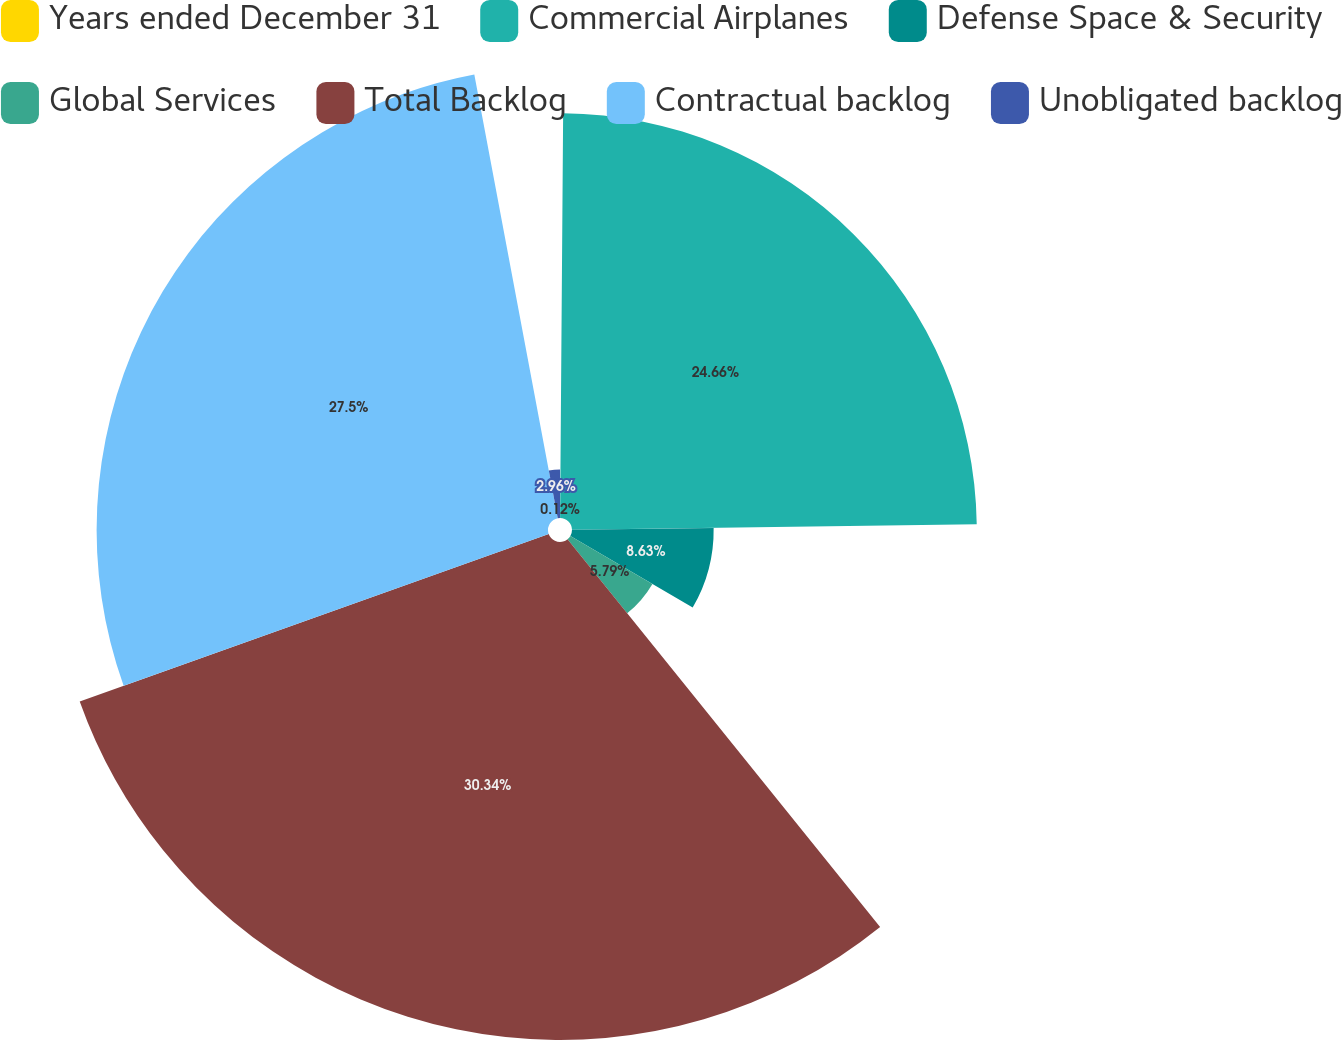Convert chart to OTSL. <chart><loc_0><loc_0><loc_500><loc_500><pie_chart><fcel>Years ended December 31<fcel>Commercial Airplanes<fcel>Defense Space & Security<fcel>Global Services<fcel>Total Backlog<fcel>Contractual backlog<fcel>Unobligated backlog<nl><fcel>0.12%<fcel>24.66%<fcel>8.63%<fcel>5.79%<fcel>30.34%<fcel>27.5%<fcel>2.96%<nl></chart> 